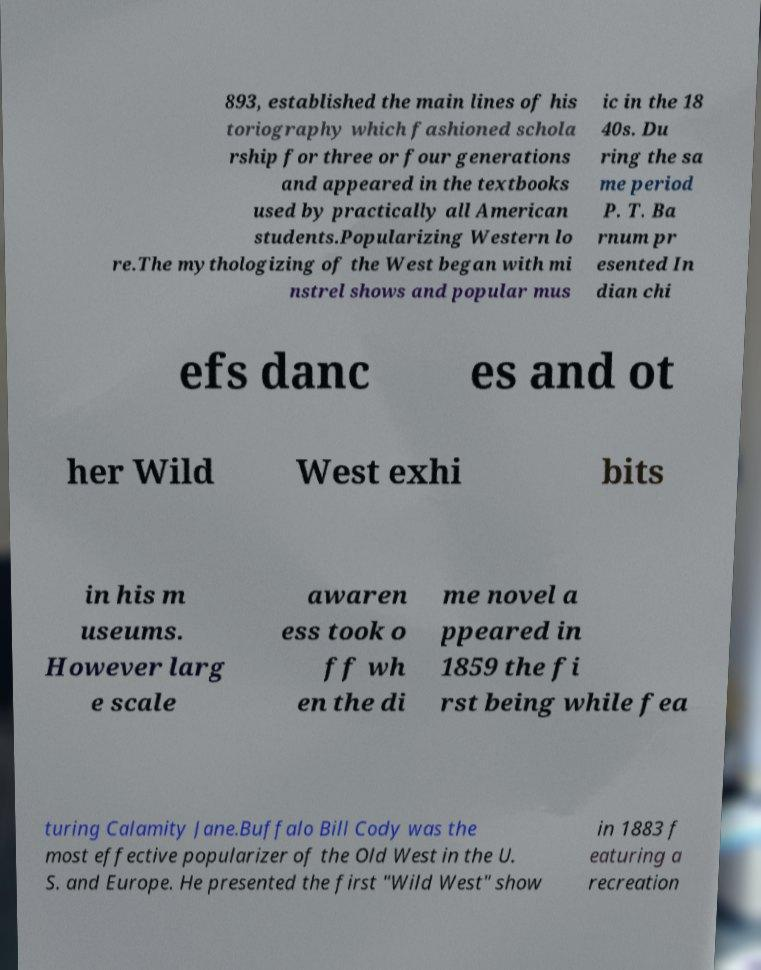There's text embedded in this image that I need extracted. Can you transcribe it verbatim? 893, established the main lines of his toriography which fashioned schola rship for three or four generations and appeared in the textbooks used by practically all American students.Popularizing Western lo re.The mythologizing of the West began with mi nstrel shows and popular mus ic in the 18 40s. Du ring the sa me period P. T. Ba rnum pr esented In dian chi efs danc es and ot her Wild West exhi bits in his m useums. However larg e scale awaren ess took o ff wh en the di me novel a ppeared in 1859 the fi rst being while fea turing Calamity Jane.Buffalo Bill Cody was the most effective popularizer of the Old West in the U. S. and Europe. He presented the first "Wild West" show in 1883 f eaturing a recreation 